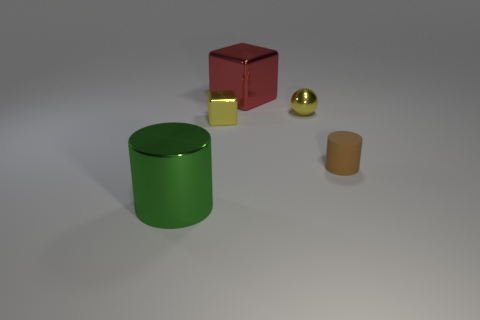Add 1 green cylinders. How many objects exist? 6 Subtract all blocks. How many objects are left? 3 Subtract 0 green cubes. How many objects are left? 5 Subtract all tiny brown rubber cylinders. Subtract all cubes. How many objects are left? 2 Add 1 rubber cylinders. How many rubber cylinders are left? 2 Add 5 yellow blocks. How many yellow blocks exist? 6 